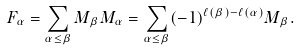Convert formula to latex. <formula><loc_0><loc_0><loc_500><loc_500>F _ { \alpha } = \sum _ { \alpha \leq \beta } M _ { \beta } M _ { \alpha } = \sum _ { \alpha \leq \beta } ( - 1 ) ^ { \ell ( \beta ) - \ell ( \alpha ) } M _ { \beta } .</formula> 